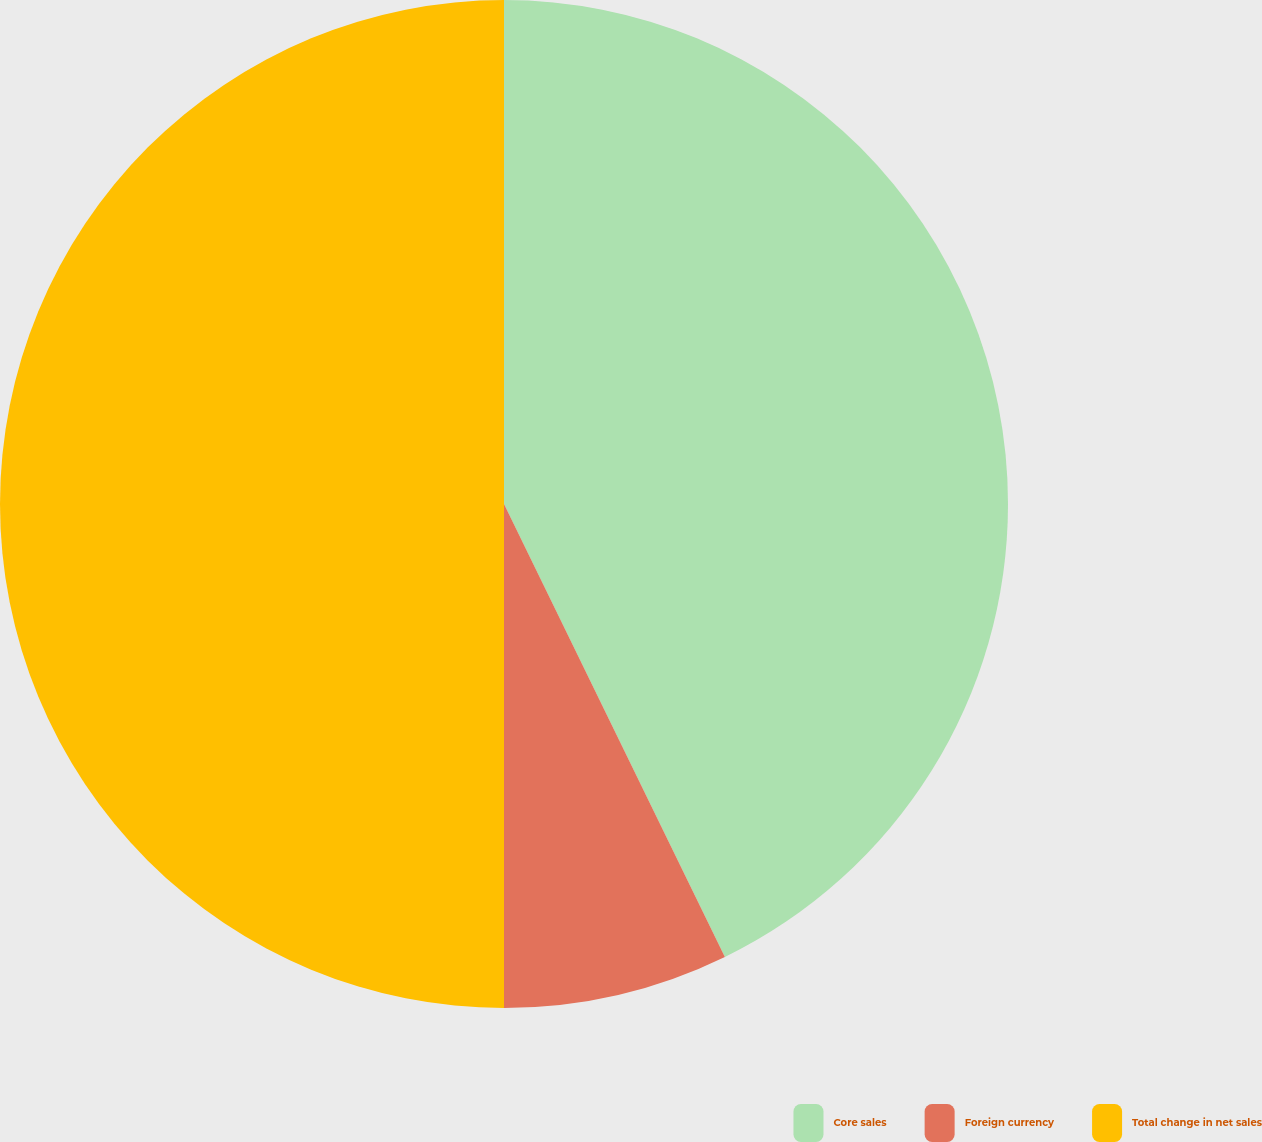<chart> <loc_0><loc_0><loc_500><loc_500><pie_chart><fcel>Core sales<fcel>Foreign currency<fcel>Total change in net sales<nl><fcel>42.78%<fcel>7.22%<fcel>50.0%<nl></chart> 